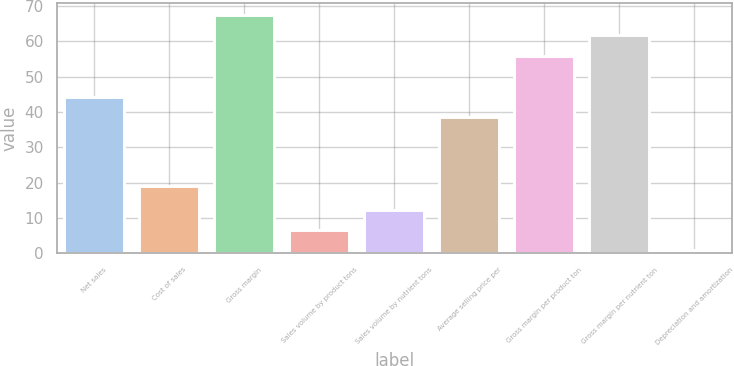<chart> <loc_0><loc_0><loc_500><loc_500><bar_chart><fcel>Net sales<fcel>Cost of sales<fcel>Gross margin<fcel>Sales volume by product tons<fcel>Sales volume by nutrient tons<fcel>Average selling price per<fcel>Gross margin per product ton<fcel>Gross margin per nutrient ton<fcel>Depreciation and amortization<nl><fcel>44.4<fcel>19<fcel>67.4<fcel>6.7<fcel>12.4<fcel>38.7<fcel>56<fcel>61.7<fcel>1<nl></chart> 